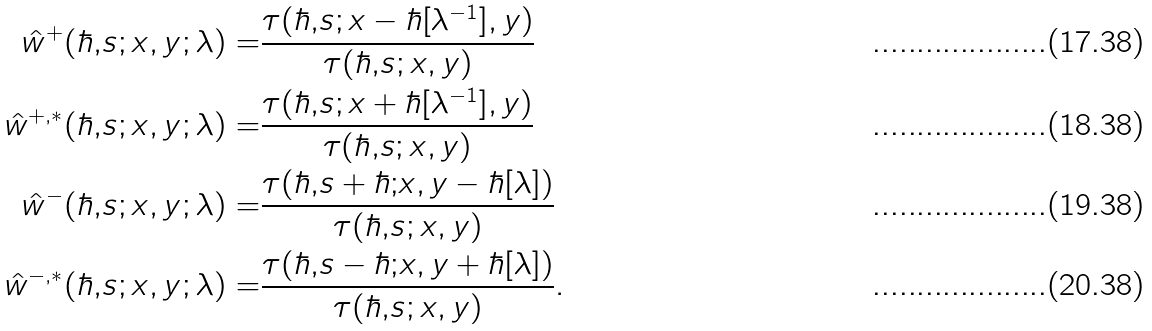<formula> <loc_0><loc_0><loc_500><loc_500>\hat { w } ^ { + } ( \hbar { , } s ; x , y ; \lambda ) = & \frac { \tau ( \hbar { , } s ; x - \hbar { [ } \lambda ^ { - 1 } ] , y ) } { \tau ( \hbar { , } s ; x , y ) } \\ \hat { w } ^ { + , * } ( \hbar { , } s ; x , y ; \lambda ) = & \frac { \tau ( \hbar { , } s ; x + \hbar { [ } \lambda ^ { - 1 } ] , y ) } { \tau ( \hbar { , } s ; x , y ) } \\ \hat { w } ^ { - } ( \hbar { , } s ; x , y ; \lambda ) = & \frac { \tau ( \hbar { , } s + \hbar { ; } x , y - \hbar { [ } \lambda ] ) } { \tau ( \hbar { , } s ; x , y ) } \\ \hat { w } ^ { - , * } ( \hbar { , } s ; x , y ; \lambda ) = & \frac { \tau ( \hbar { , } s - \hbar { ; } x , y + \hbar { [ } \lambda ] ) } { \tau ( \hbar { , } s ; x , y ) } .</formula> 